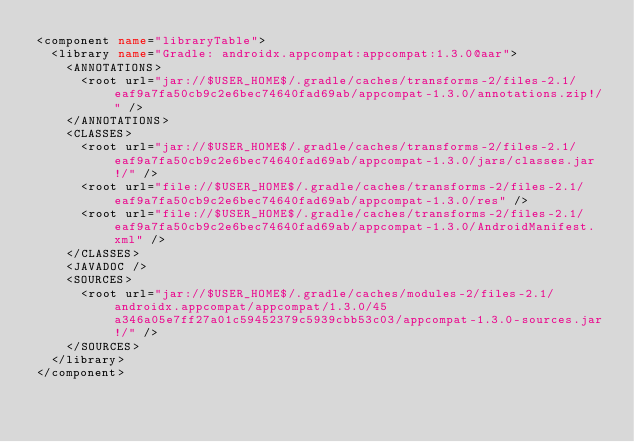<code> <loc_0><loc_0><loc_500><loc_500><_XML_><component name="libraryTable">
  <library name="Gradle: androidx.appcompat:appcompat:1.3.0@aar">
    <ANNOTATIONS>
      <root url="jar://$USER_HOME$/.gradle/caches/transforms-2/files-2.1/eaf9a7fa50cb9c2e6bec74640fad69ab/appcompat-1.3.0/annotations.zip!/" />
    </ANNOTATIONS>
    <CLASSES>
      <root url="jar://$USER_HOME$/.gradle/caches/transforms-2/files-2.1/eaf9a7fa50cb9c2e6bec74640fad69ab/appcompat-1.3.0/jars/classes.jar!/" />
      <root url="file://$USER_HOME$/.gradle/caches/transforms-2/files-2.1/eaf9a7fa50cb9c2e6bec74640fad69ab/appcompat-1.3.0/res" />
      <root url="file://$USER_HOME$/.gradle/caches/transforms-2/files-2.1/eaf9a7fa50cb9c2e6bec74640fad69ab/appcompat-1.3.0/AndroidManifest.xml" />
    </CLASSES>
    <JAVADOC />
    <SOURCES>
      <root url="jar://$USER_HOME$/.gradle/caches/modules-2/files-2.1/androidx.appcompat/appcompat/1.3.0/45a346a05e7ff27a01c59452379c5939cbb53c03/appcompat-1.3.0-sources.jar!/" />
    </SOURCES>
  </library>
</component></code> 